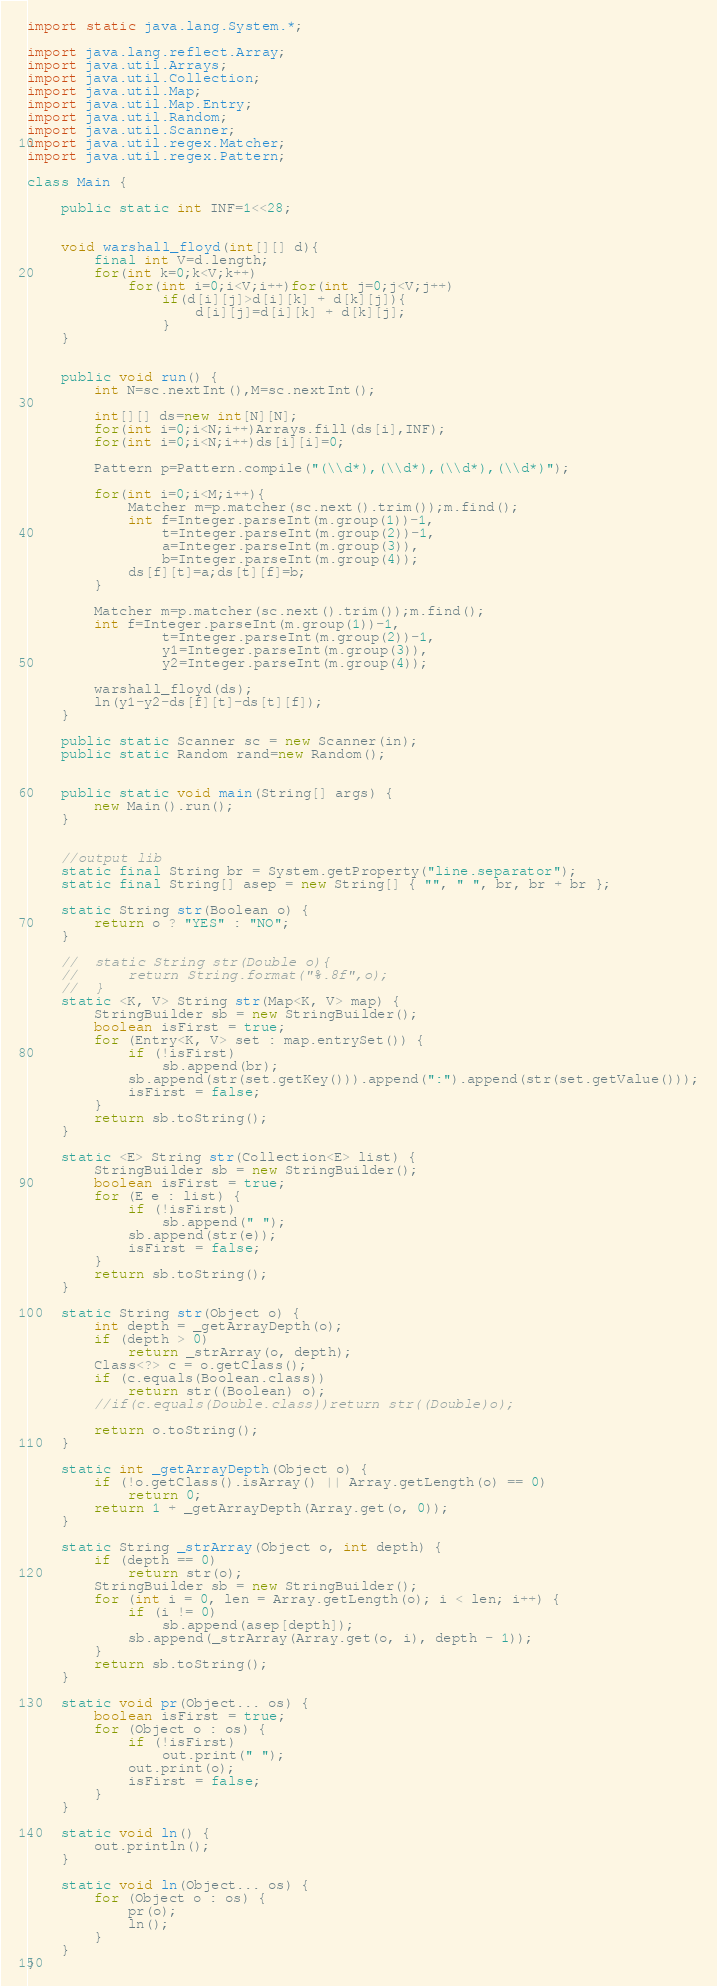Convert code to text. <code><loc_0><loc_0><loc_500><loc_500><_Java_>
import static java.lang.System.*;

import java.lang.reflect.Array;
import java.util.Arrays;
import java.util.Collection;
import java.util.Map;
import java.util.Map.Entry;
import java.util.Random;
import java.util.Scanner;
import java.util.regex.Matcher;
import java.util.regex.Pattern;

class Main {

    public static int INF=1<<28;


    void warshall_floyd(int[][] d){
		final int V=d.length;
	    for(int k=0;k<V;k++)
	    	for(int i=0;i<V;i++)for(int j=0;j<V;j++)
	    		if(d[i][j]>d[i][k] + d[k][j]){
	    			d[i][j]=d[i][k] + d[k][j];
	    		}
	}


    public void run() {
    	int N=sc.nextInt(),M=sc.nextInt();

    	int[][] ds=new int[N][N];
    	for(int i=0;i<N;i++)Arrays.fill(ds[i],INF);
    	for(int i=0;i<N;i++)ds[i][i]=0;

    	Pattern p=Pattern.compile("(\\d*),(\\d*),(\\d*),(\\d*)");

    	for(int i=0;i<M;i++){
    		Matcher m=p.matcher(sc.next().trim());m.find();
    		int f=Integer.parseInt(m.group(1))-1,
    	    	t=Integer.parseInt(m.group(2))-1,
    	    	a=Integer.parseInt(m.group(3)),
        		b=Integer.parseInt(m.group(4));
    		ds[f][t]=a;ds[t][f]=b;
    	}

		Matcher m=p.matcher(sc.next().trim());m.find();
		int f=Integer.parseInt(m.group(1))-1,
    	    	t=Integer.parseInt(m.group(2))-1,
    	    	y1=Integer.parseInt(m.group(3)),
        		y2=Integer.parseInt(m.group(4));

    	warshall_floyd(ds);
		ln(y1-y2-ds[f][t]-ds[t][f]);
    }

    public static Scanner sc = new Scanner(in);
    public static Random rand=new Random();


    public static void main(String[] args) {
        new Main().run();
    }


	//output lib
	static final String br = System.getProperty("line.separator");
	static final String[] asep = new String[] { "", " ", br, br + br };

	static String str(Boolean o) {
		return o ? "YES" : "NO";
	}

	//	static String str(Double o){
	//		return String.format("%.8f",o);
	//	}
	static <K, V> String str(Map<K, V> map) {
		StringBuilder sb = new StringBuilder();
		boolean isFirst = true;
		for (Entry<K, V> set : map.entrySet()) {
			if (!isFirst)
				sb.append(br);
			sb.append(str(set.getKey())).append(":").append(str(set.getValue()));
			isFirst = false;
		}
		return sb.toString();
	}

	static <E> String str(Collection<E> list) {
		StringBuilder sb = new StringBuilder();
		boolean isFirst = true;
		for (E e : list) {
			if (!isFirst)
				sb.append(" ");
			sb.append(str(e));
			isFirst = false;
		}
		return sb.toString();
	}

	static String str(Object o) {
		int depth = _getArrayDepth(o);
		if (depth > 0)
			return _strArray(o, depth);
		Class<?> c = o.getClass();
		if (c.equals(Boolean.class))
			return str((Boolean) o);
		//if(c.equals(Double.class))return str((Double)o);

		return o.toString();
	}

	static int _getArrayDepth(Object o) {
		if (!o.getClass().isArray() || Array.getLength(o) == 0)
			return 0;
		return 1 + _getArrayDepth(Array.get(o, 0));
	}

	static String _strArray(Object o, int depth) {
		if (depth == 0)
			return str(o);
		StringBuilder sb = new StringBuilder();
		for (int i = 0, len = Array.getLength(o); i < len; i++) {
			if (i != 0)
				sb.append(asep[depth]);
			sb.append(_strArray(Array.get(o, i), depth - 1));
		}
		return sb.toString();
	}

	static void pr(Object... os) {
		boolean isFirst = true;
		for (Object o : os) {
			if (!isFirst)
				out.print(" ");
			out.print(o);
			isFirst = false;
		}
	}

	static void ln() {
		out.println();
	}

	static void ln(Object... os) {
		for (Object o : os) {
			pr(o);
			ln();
		}
	}
}</code> 